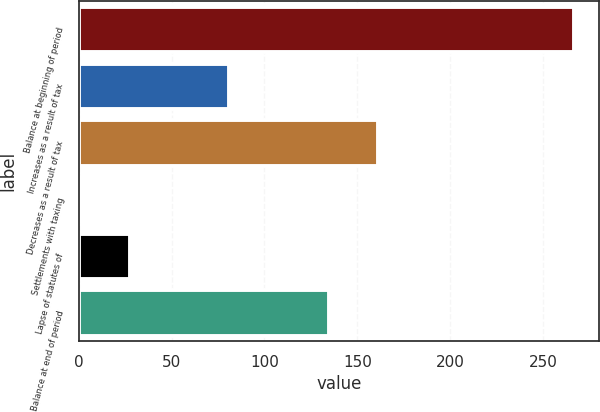Convert chart. <chart><loc_0><loc_0><loc_500><loc_500><bar_chart><fcel>Balance at beginning of period<fcel>Increases as a result of tax<fcel>Decreases as a result of tax<fcel>Settlements with taxing<fcel>Lapse of statutes of<fcel>Balance at end of period<nl><fcel>266.9<fcel>80.77<fcel>161.39<fcel>1<fcel>27.59<fcel>134.8<nl></chart> 